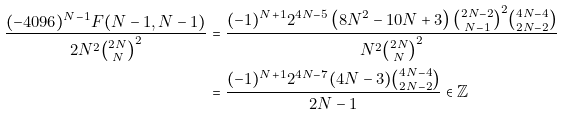<formula> <loc_0><loc_0><loc_500><loc_500>\frac { ( - 4 0 9 6 ) ^ { N - 1 } F ( N - 1 , N - 1 ) } { 2 N ^ { 2 } \binom { 2 N } { N } ^ { 2 } } & = \frac { ( - 1 ) ^ { N + 1 } 2 ^ { 4 N - 5 } \left ( 8 N ^ { 2 } - 1 0 N + 3 \right ) \binom { 2 N - 2 } { N - 1 } ^ { 2 } \binom { 4 N - 4 } { 2 N - 2 } } { N ^ { 2 } \binom { 2 N } { N } ^ { 2 } } \\ & = \frac { ( - 1 ) ^ { N + 1 } 2 ^ { 4 N - 7 } ( 4 N - 3 ) \binom { 4 N - 4 } { 2 N - 2 } } { 2 N - 1 } \in \mathbb { Z }</formula> 